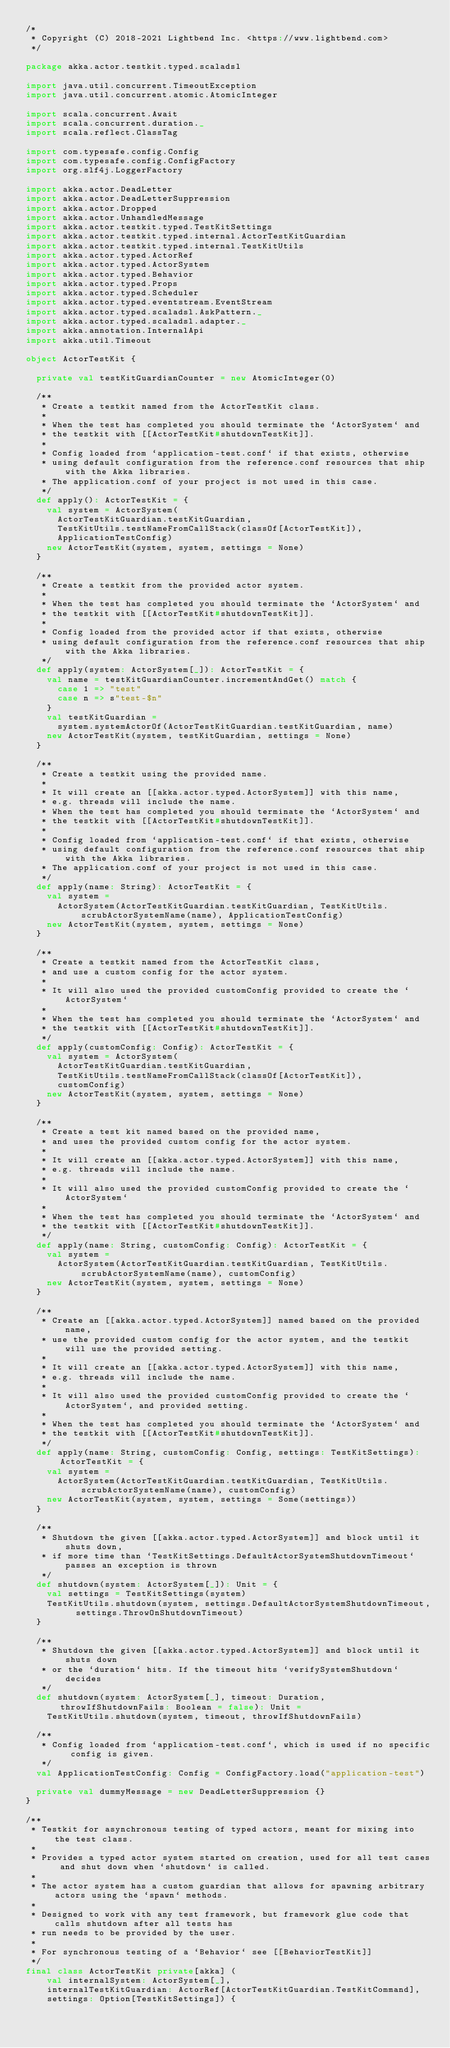<code> <loc_0><loc_0><loc_500><loc_500><_Scala_>/*
 * Copyright (C) 2018-2021 Lightbend Inc. <https://www.lightbend.com>
 */

package akka.actor.testkit.typed.scaladsl

import java.util.concurrent.TimeoutException
import java.util.concurrent.atomic.AtomicInteger

import scala.concurrent.Await
import scala.concurrent.duration._
import scala.reflect.ClassTag

import com.typesafe.config.Config
import com.typesafe.config.ConfigFactory
import org.slf4j.LoggerFactory

import akka.actor.DeadLetter
import akka.actor.DeadLetterSuppression
import akka.actor.Dropped
import akka.actor.UnhandledMessage
import akka.actor.testkit.typed.TestKitSettings
import akka.actor.testkit.typed.internal.ActorTestKitGuardian
import akka.actor.testkit.typed.internal.TestKitUtils
import akka.actor.typed.ActorRef
import akka.actor.typed.ActorSystem
import akka.actor.typed.Behavior
import akka.actor.typed.Props
import akka.actor.typed.Scheduler
import akka.actor.typed.eventstream.EventStream
import akka.actor.typed.scaladsl.AskPattern._
import akka.actor.typed.scaladsl.adapter._
import akka.annotation.InternalApi
import akka.util.Timeout

object ActorTestKit {

  private val testKitGuardianCounter = new AtomicInteger(0)

  /**
   * Create a testkit named from the ActorTestKit class.
   *
   * When the test has completed you should terminate the `ActorSystem` and
   * the testkit with [[ActorTestKit#shutdownTestKit]].
   *
   * Config loaded from `application-test.conf` if that exists, otherwise
   * using default configuration from the reference.conf resources that ship with the Akka libraries.
   * The application.conf of your project is not used in this case.
   */
  def apply(): ActorTestKit = {
    val system = ActorSystem(
      ActorTestKitGuardian.testKitGuardian,
      TestKitUtils.testNameFromCallStack(classOf[ActorTestKit]),
      ApplicationTestConfig)
    new ActorTestKit(system, system, settings = None)
  }

  /**
   * Create a testkit from the provided actor system.
   *
   * When the test has completed you should terminate the `ActorSystem` and
   * the testkit with [[ActorTestKit#shutdownTestKit]].
   *
   * Config loaded from the provided actor if that exists, otherwise
   * using default configuration from the reference.conf resources that ship with the Akka libraries.
   */
  def apply(system: ActorSystem[_]): ActorTestKit = {
    val name = testKitGuardianCounter.incrementAndGet() match {
      case 1 => "test"
      case n => s"test-$n"
    }
    val testKitGuardian =
      system.systemActorOf(ActorTestKitGuardian.testKitGuardian, name)
    new ActorTestKit(system, testKitGuardian, settings = None)
  }

  /**
   * Create a testkit using the provided name.
   *
   * It will create an [[akka.actor.typed.ActorSystem]] with this name,
   * e.g. threads will include the name.
   * When the test has completed you should terminate the `ActorSystem` and
   * the testkit with [[ActorTestKit#shutdownTestKit]].
   *
   * Config loaded from `application-test.conf` if that exists, otherwise
   * using default configuration from the reference.conf resources that ship with the Akka libraries.
   * The application.conf of your project is not used in this case.
   */
  def apply(name: String): ActorTestKit = {
    val system =
      ActorSystem(ActorTestKitGuardian.testKitGuardian, TestKitUtils.scrubActorSystemName(name), ApplicationTestConfig)
    new ActorTestKit(system, system, settings = None)
  }

  /**
   * Create a testkit named from the ActorTestKit class,
   * and use a custom config for the actor system.
   *
   * It will also used the provided customConfig provided to create the `ActorSystem`
   *
   * When the test has completed you should terminate the `ActorSystem` and
   * the testkit with [[ActorTestKit#shutdownTestKit]].
   */
  def apply(customConfig: Config): ActorTestKit = {
    val system = ActorSystem(
      ActorTestKitGuardian.testKitGuardian,
      TestKitUtils.testNameFromCallStack(classOf[ActorTestKit]),
      customConfig)
    new ActorTestKit(system, system, settings = None)
  }

  /**
   * Create a test kit named based on the provided name,
   * and uses the provided custom config for the actor system.
   *
   * It will create an [[akka.actor.typed.ActorSystem]] with this name,
   * e.g. threads will include the name.
   *
   * It will also used the provided customConfig provided to create the `ActorSystem`
   *
   * When the test has completed you should terminate the `ActorSystem` and
   * the testkit with [[ActorTestKit#shutdownTestKit]].
   */
  def apply(name: String, customConfig: Config): ActorTestKit = {
    val system =
      ActorSystem(ActorTestKitGuardian.testKitGuardian, TestKitUtils.scrubActorSystemName(name), customConfig)
    new ActorTestKit(system, system, settings = None)
  }

  /**
   * Create an [[akka.actor.typed.ActorSystem]] named based on the provided name,
   * use the provided custom config for the actor system, and the testkit will use the provided setting.
   *
   * It will create an [[akka.actor.typed.ActorSystem]] with this name,
   * e.g. threads will include the name.
   *
   * It will also used the provided customConfig provided to create the `ActorSystem`, and provided setting.
   *
   * When the test has completed you should terminate the `ActorSystem` and
   * the testkit with [[ActorTestKit#shutdownTestKit]].
   */
  def apply(name: String, customConfig: Config, settings: TestKitSettings): ActorTestKit = {
    val system =
      ActorSystem(ActorTestKitGuardian.testKitGuardian, TestKitUtils.scrubActorSystemName(name), customConfig)
    new ActorTestKit(system, system, settings = Some(settings))
  }

  /**
   * Shutdown the given [[akka.actor.typed.ActorSystem]] and block until it shuts down,
   * if more time than `TestKitSettings.DefaultActorSystemShutdownTimeout` passes an exception is thrown
   */
  def shutdown(system: ActorSystem[_]): Unit = {
    val settings = TestKitSettings(system)
    TestKitUtils.shutdown(system, settings.DefaultActorSystemShutdownTimeout, settings.ThrowOnShutdownTimeout)
  }

  /**
   * Shutdown the given [[akka.actor.typed.ActorSystem]] and block until it shuts down
   * or the `duration` hits. If the timeout hits `verifySystemShutdown` decides
   */
  def shutdown(system: ActorSystem[_], timeout: Duration, throwIfShutdownFails: Boolean = false): Unit =
    TestKitUtils.shutdown(system, timeout, throwIfShutdownFails)

  /**
   * Config loaded from `application-test.conf`, which is used if no specific config is given.
   */
  val ApplicationTestConfig: Config = ConfigFactory.load("application-test")

  private val dummyMessage = new DeadLetterSuppression {}
}

/**
 * Testkit for asynchronous testing of typed actors, meant for mixing into the test class.
 *
 * Provides a typed actor system started on creation, used for all test cases and shut down when `shutdown` is called.
 *
 * The actor system has a custom guardian that allows for spawning arbitrary actors using the `spawn` methods.
 *
 * Designed to work with any test framework, but framework glue code that calls shutdown after all tests has
 * run needs to be provided by the user.
 *
 * For synchronous testing of a `Behavior` see [[BehaviorTestKit]]
 */
final class ActorTestKit private[akka] (
    val internalSystem: ActorSystem[_],
    internalTestKitGuardian: ActorRef[ActorTestKitGuardian.TestKitCommand],
    settings: Option[TestKitSettings]) {
</code> 